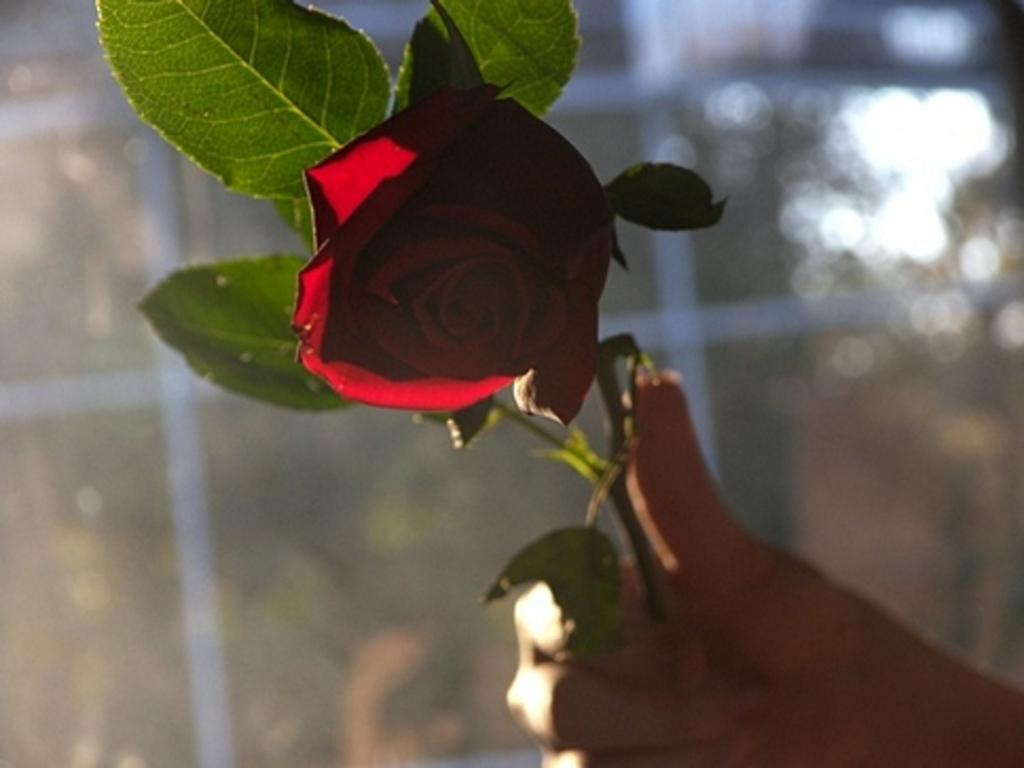Who or what is present in the image? There is a person in the image. What is the person holding in the image? The person is holding a rose. Can you describe the rose in the image? The rose has leaves on its stem. What can be seen in the background of the image? There appears to be a window in the background of the image. What type of steel is being used for the destruction of the zebra in the image? There is no zebra or steel present in the image, and therefore no destruction can be observed. 